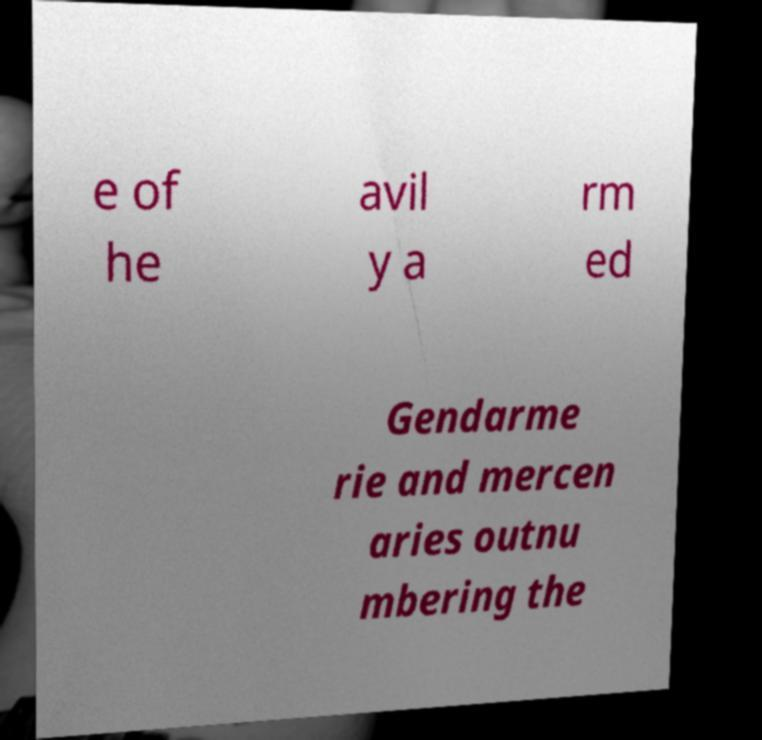What messages or text are displayed in this image? I need them in a readable, typed format. e of he avil y a rm ed Gendarme rie and mercen aries outnu mbering the 